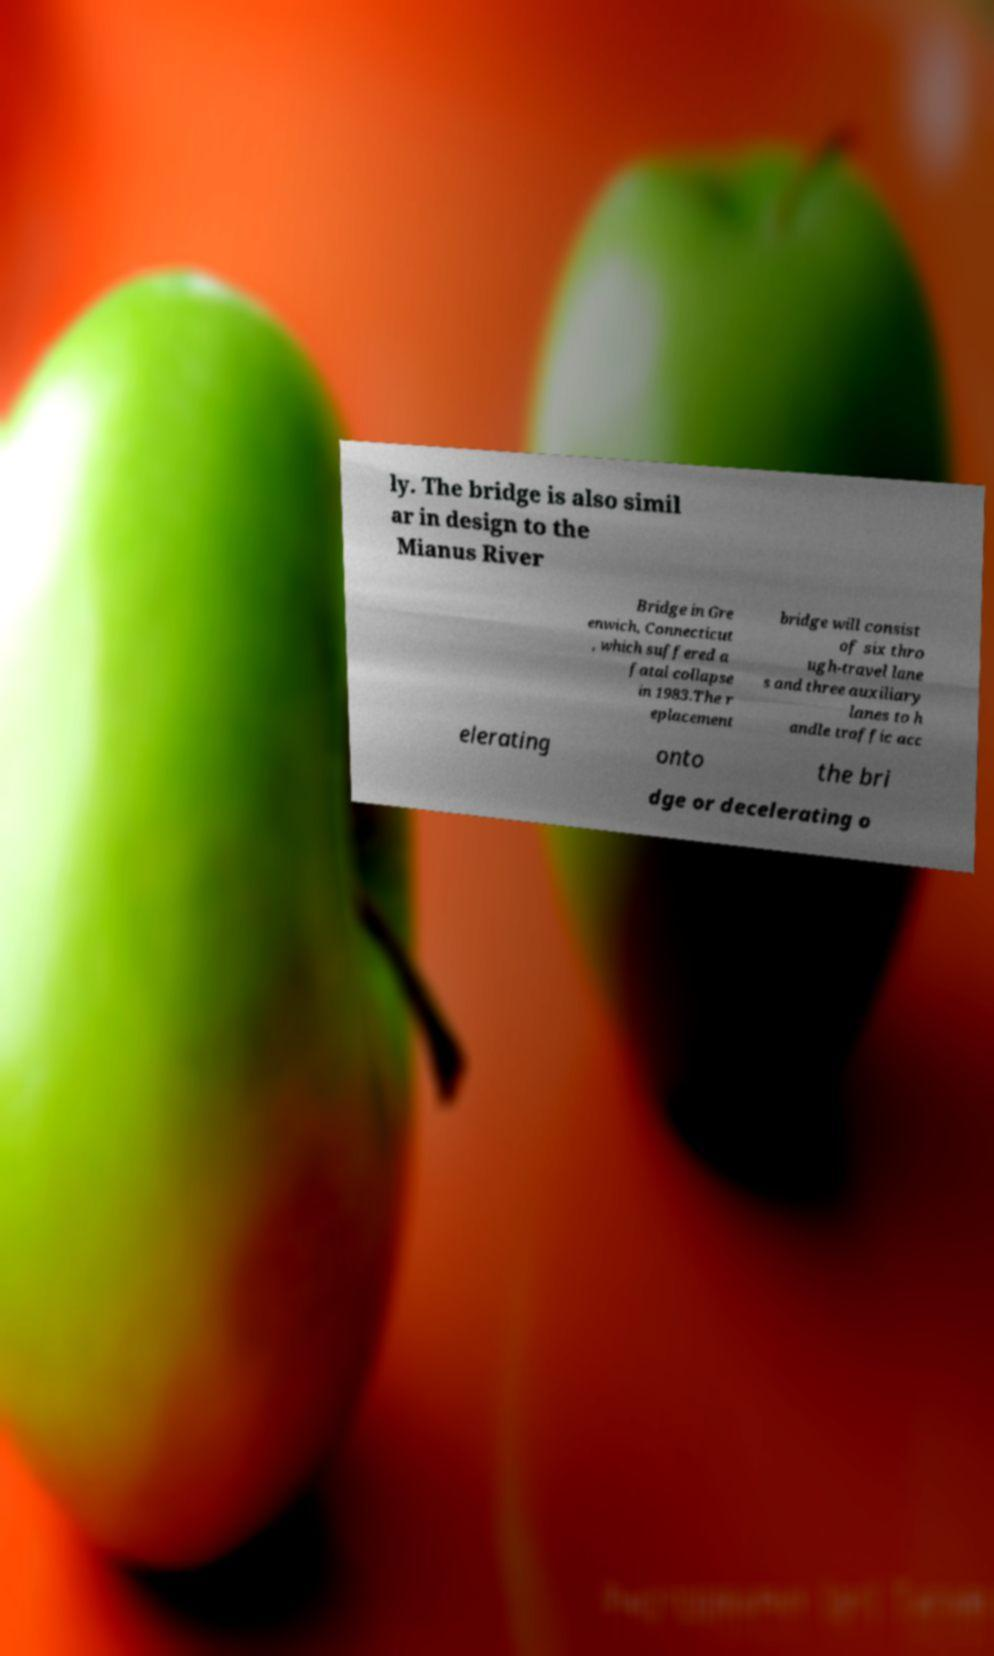I need the written content from this picture converted into text. Can you do that? ly. The bridge is also simil ar in design to the Mianus River Bridge in Gre enwich, Connecticut , which suffered a fatal collapse in 1983.The r eplacement bridge will consist of six thro ugh-travel lane s and three auxiliary lanes to h andle traffic acc elerating onto the bri dge or decelerating o 